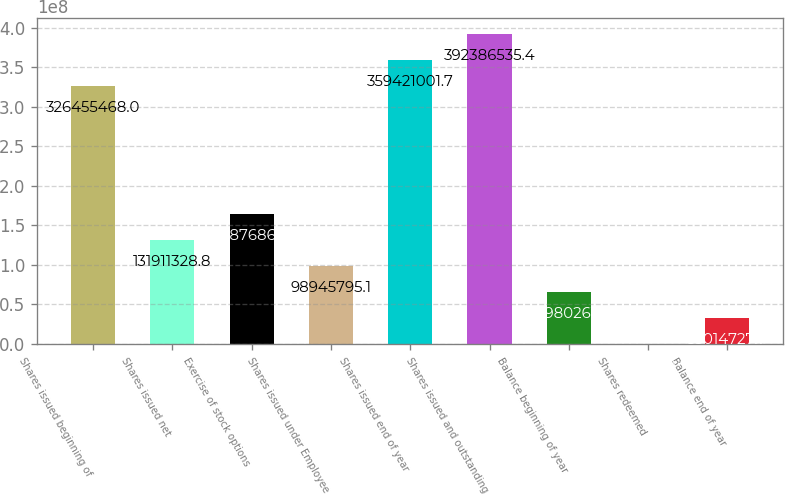Convert chart. <chart><loc_0><loc_0><loc_500><loc_500><bar_chart><fcel>Shares issued beginning of<fcel>Shares issued net<fcel>Exercise of stock options<fcel>Shares issued under Employee<fcel>Shares issued end of year<fcel>Shares issued and outstanding<fcel>Balance beginning of year<fcel>Shares redeemed<fcel>Balance end of year<nl><fcel>3.26455e+08<fcel>1.31911e+08<fcel>1.64877e+08<fcel>9.89458e+07<fcel>3.59421e+08<fcel>3.92387e+08<fcel>6.59803e+07<fcel>49194<fcel>3.30147e+07<nl></chart> 